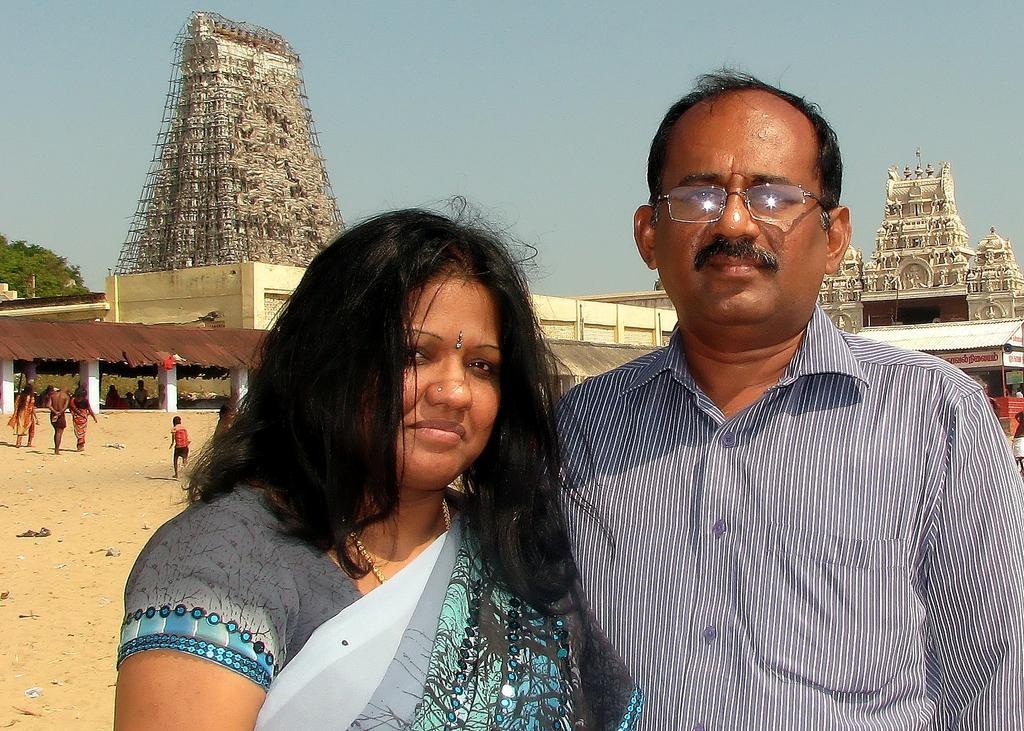In one or two sentences, can you explain what this image depicts? This picture shows a man and a woman standing. We see few temples on the back and we see a tree and few people walking and we see a blue sky. 